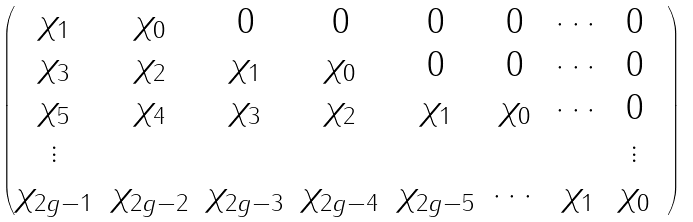<formula> <loc_0><loc_0><loc_500><loc_500>\begin{pmatrix} \chi _ { 1 } & \chi _ { 0 } & 0 & 0 & 0 & 0 & \cdots & 0 \\ \chi _ { 3 } & \chi _ { 2 } & \chi _ { 1 } & \chi _ { 0 } & 0 & 0 & \cdots & 0 \\ \chi _ { 5 } & \chi _ { 4 } & \chi _ { 3 } & \chi _ { 2 } & \chi _ { 1 } & \chi _ { 0 } & \cdots & 0 \\ \vdots & & & & & & & \vdots & \\ \chi _ { 2 g - 1 } & \chi _ { 2 g - 2 } & \chi _ { 2 g - 3 } & \chi _ { 2 g - 4 } & \chi _ { 2 g - 5 } & \cdots & \chi _ { 1 } & \chi _ { 0 } \end{pmatrix}</formula> 